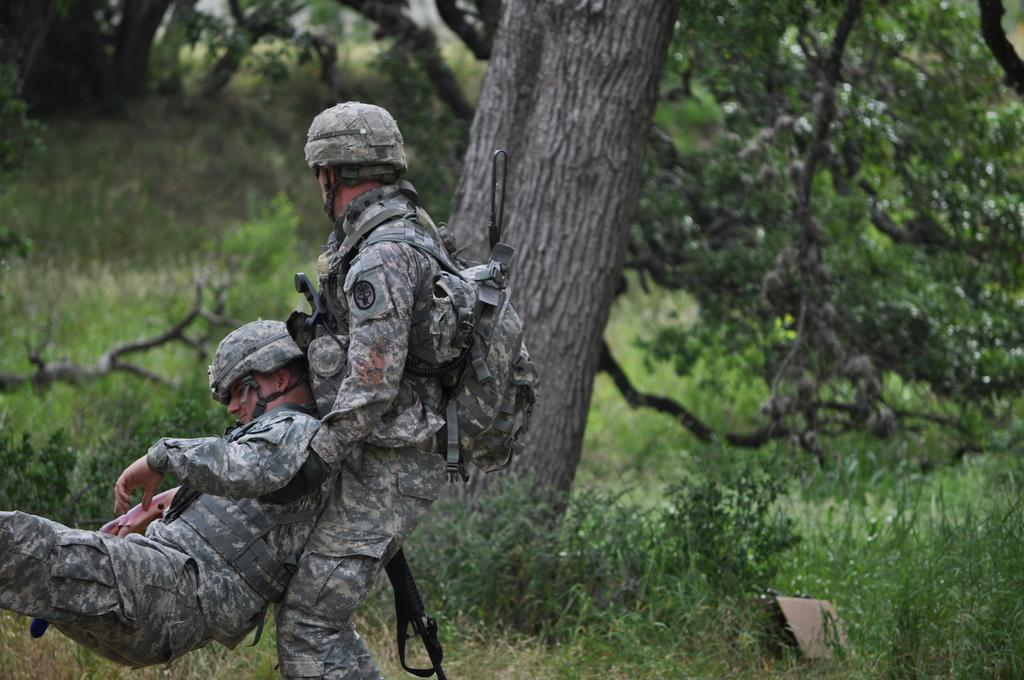What is happening between the two army personnel in the image? One army personnel is dragging another army personnel in the image. What can be seen in the background of the image? Plants and trees are visible in the background of the image. How many cows are present in the image? There are no cows present in the image. What type of animal can be seen in the image? There are no animals visible in the image; only army personnel and plants/trees are present. 